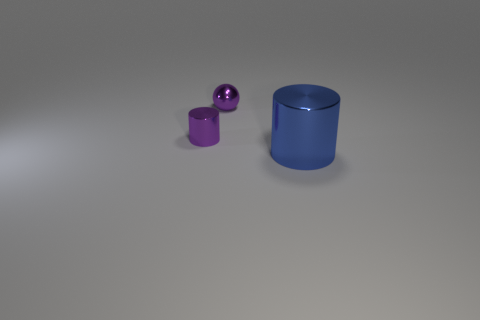There is a cylinder that is on the left side of the thing to the right of the tiny object that is behind the purple cylinder; what is its size?
Provide a succinct answer. Small. Is there a small thing that has the same color as the sphere?
Your answer should be compact. Yes. How many purple metal balls are there?
Your answer should be very brief. 1. The purple thing to the left of the purple metal thing behind the cylinder to the left of the big cylinder is made of what material?
Provide a succinct answer. Metal. Are there any large green cylinders made of the same material as the purple cylinder?
Offer a terse response. No. Does the blue cylinder have the same material as the purple ball?
Ensure brevity in your answer.  Yes. How many balls are small shiny things or big yellow metal objects?
Make the answer very short. 1. The other cylinder that is made of the same material as the tiny purple cylinder is what color?
Your answer should be very brief. Blue. Is the number of purple matte balls less than the number of spheres?
Your answer should be compact. Yes. There is a shiny thing to the right of the metal sphere; does it have the same shape as the shiny thing behind the tiny purple metal cylinder?
Ensure brevity in your answer.  No. 